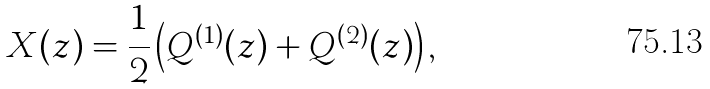<formula> <loc_0><loc_0><loc_500><loc_500>X ( z ) = \frac { 1 } { 2 } \left ( Q ^ { ( 1 ) } ( z ) + Q ^ { ( 2 ) } ( z ) \right ) ,</formula> 